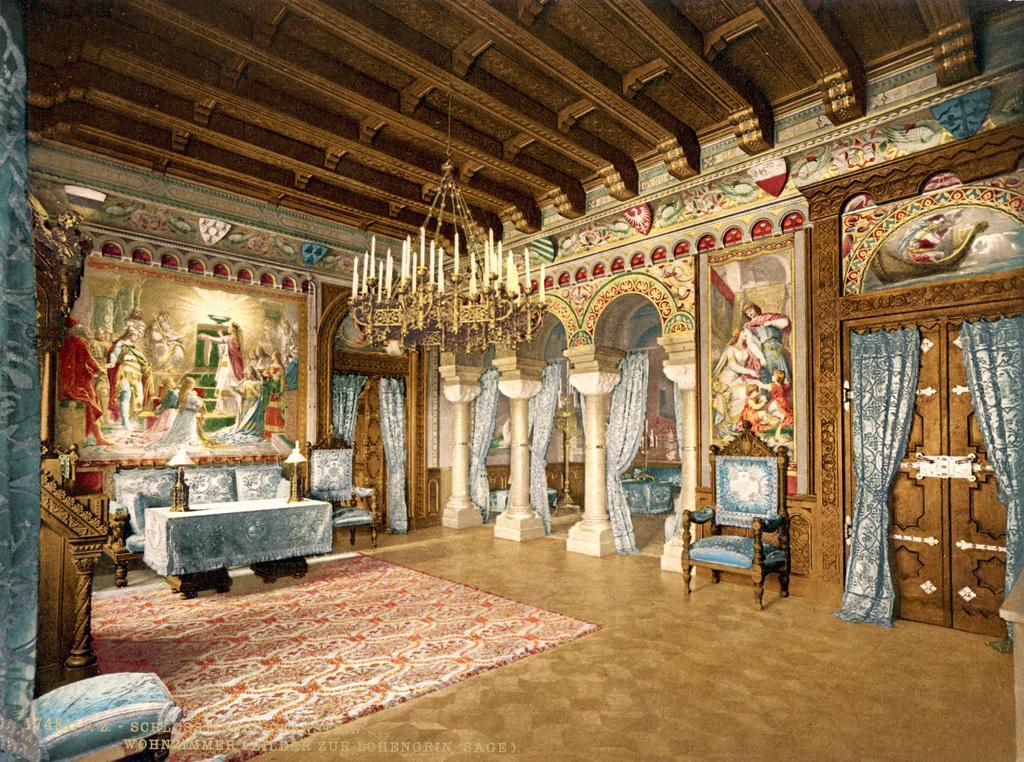How would you summarize this image in a sentence or two? This picture describes about inside view of the room, in this we can find few curtains, chairs and a table, and also we can find a painting on the wall. 